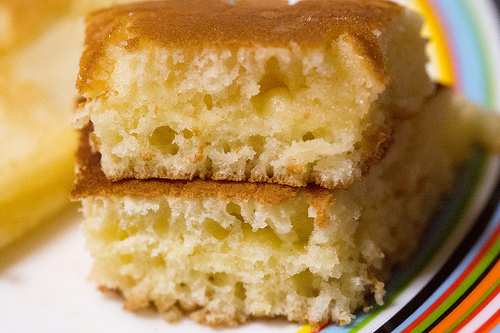<image>
Can you confirm if the cake is behind the cake? No. The cake is not behind the cake. From this viewpoint, the cake appears to be positioned elsewhere in the scene. 